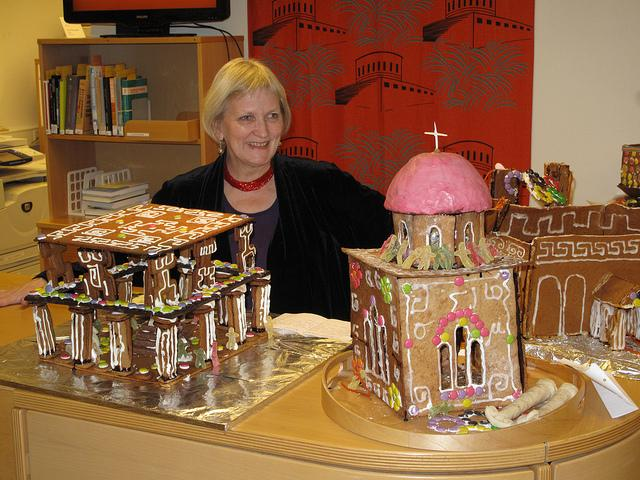What are these buildings mostly made of? gingerbread 